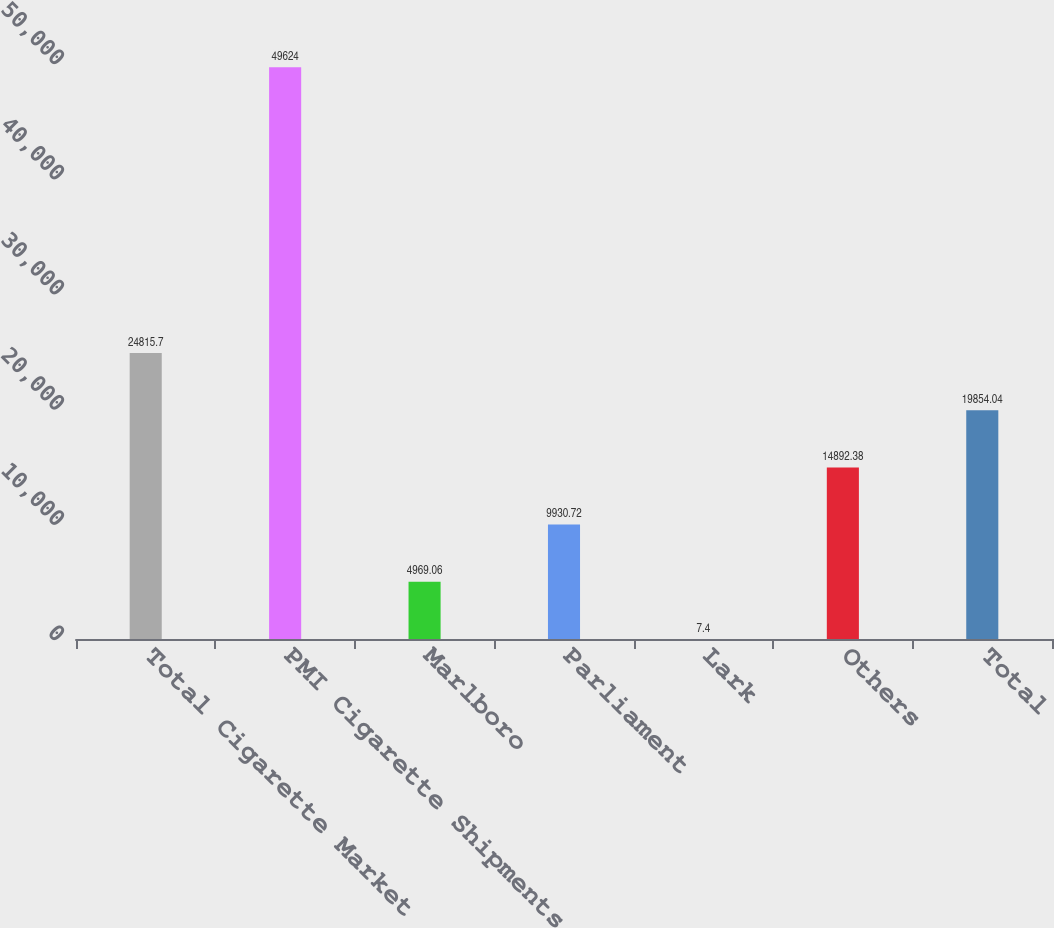Convert chart. <chart><loc_0><loc_0><loc_500><loc_500><bar_chart><fcel>Total Cigarette Market<fcel>PMI Cigarette Shipments<fcel>Marlboro<fcel>Parliament<fcel>Lark<fcel>Others<fcel>Total<nl><fcel>24815.7<fcel>49624<fcel>4969.06<fcel>9930.72<fcel>7.4<fcel>14892.4<fcel>19854<nl></chart> 